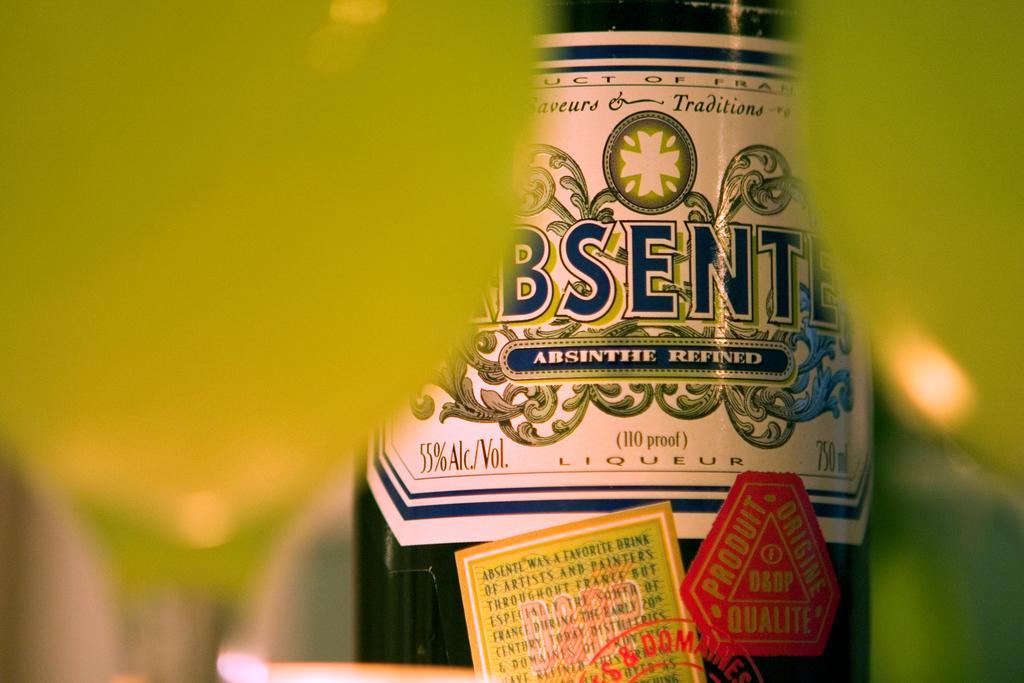<image>
Offer a succinct explanation of the picture presented. An alcoholic drink that an alcohol percentage of 55%. 